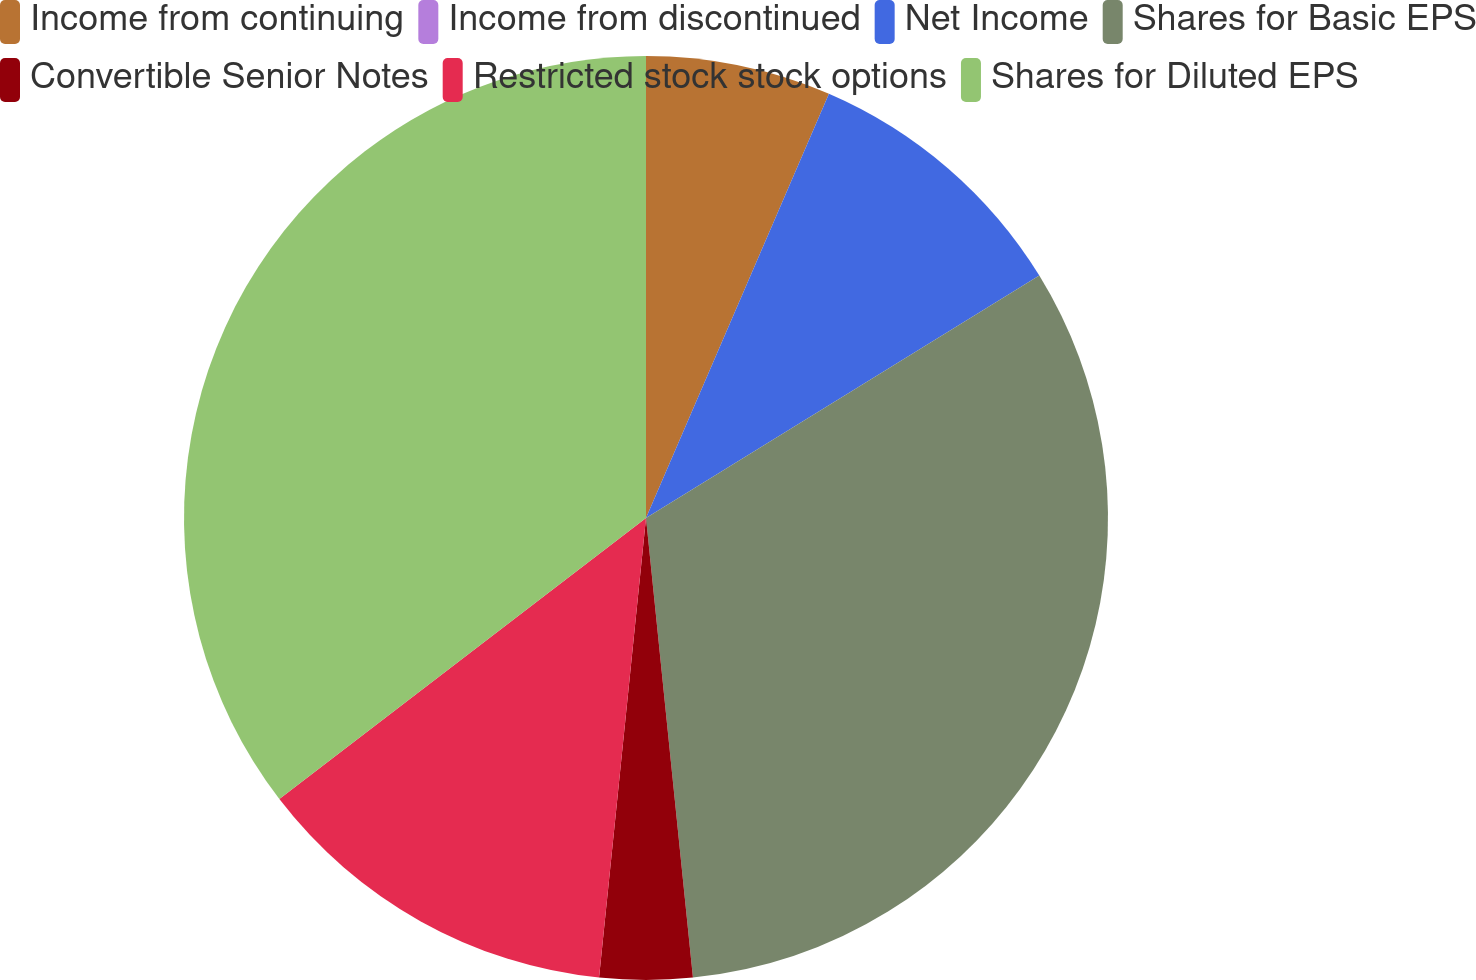Convert chart to OTSL. <chart><loc_0><loc_0><loc_500><loc_500><pie_chart><fcel>Income from continuing<fcel>Income from discontinued<fcel>Net Income<fcel>Shares for Basic EPS<fcel>Convertible Senior Notes<fcel>Restricted stock stock options<fcel>Shares for Diluted EPS<nl><fcel>6.48%<fcel>0.0%<fcel>9.73%<fcel>32.17%<fcel>3.24%<fcel>12.97%<fcel>35.41%<nl></chart> 